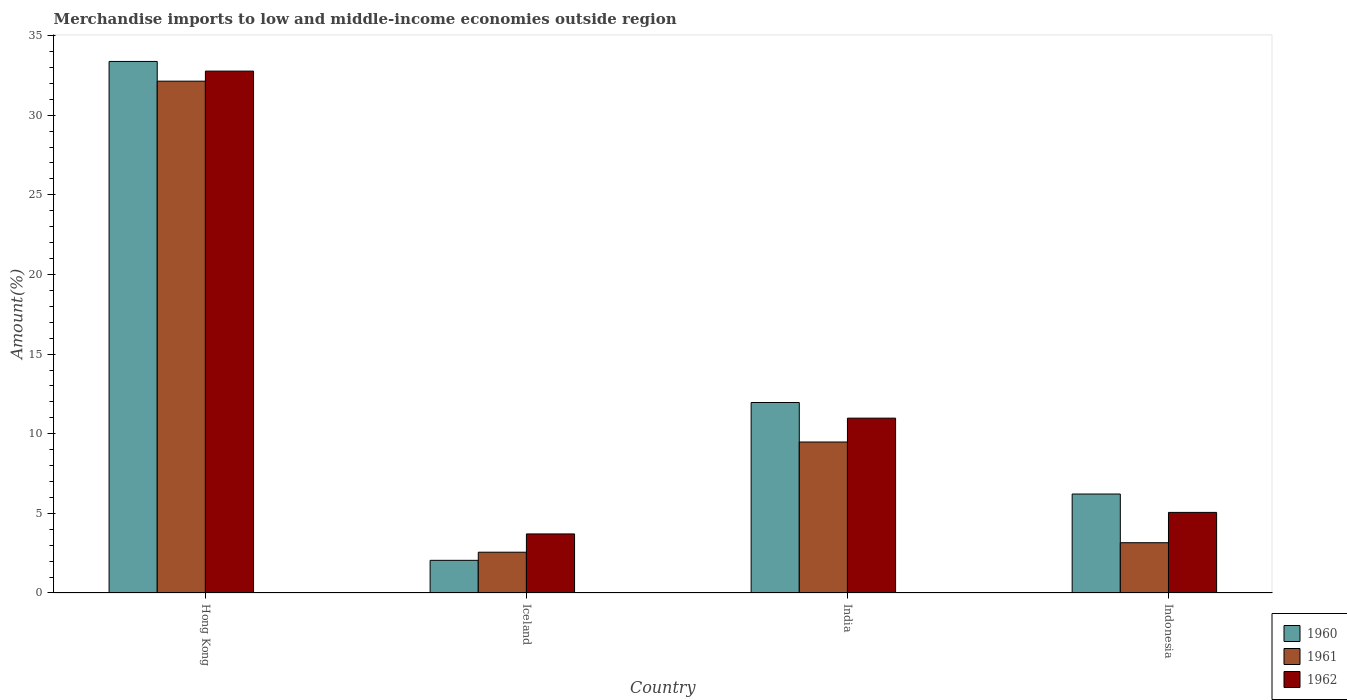How many bars are there on the 2nd tick from the left?
Give a very brief answer. 3. How many bars are there on the 3rd tick from the right?
Make the answer very short. 3. What is the label of the 4th group of bars from the left?
Your answer should be very brief. Indonesia. In how many cases, is the number of bars for a given country not equal to the number of legend labels?
Your answer should be compact. 0. What is the percentage of amount earned from merchandise imports in 1962 in Indonesia?
Offer a terse response. 5.06. Across all countries, what is the maximum percentage of amount earned from merchandise imports in 1961?
Offer a very short reply. 32.13. Across all countries, what is the minimum percentage of amount earned from merchandise imports in 1960?
Provide a short and direct response. 2.05. In which country was the percentage of amount earned from merchandise imports in 1962 maximum?
Make the answer very short. Hong Kong. What is the total percentage of amount earned from merchandise imports in 1960 in the graph?
Provide a short and direct response. 53.59. What is the difference between the percentage of amount earned from merchandise imports in 1962 in India and that in Indonesia?
Offer a very short reply. 5.92. What is the difference between the percentage of amount earned from merchandise imports in 1960 in India and the percentage of amount earned from merchandise imports in 1962 in Hong Kong?
Keep it short and to the point. -20.81. What is the average percentage of amount earned from merchandise imports in 1961 per country?
Your answer should be compact. 11.83. What is the difference between the percentage of amount earned from merchandise imports of/in 1961 and percentage of amount earned from merchandise imports of/in 1962 in Iceland?
Your answer should be very brief. -1.15. In how many countries, is the percentage of amount earned from merchandise imports in 1961 greater than 15 %?
Keep it short and to the point. 1. What is the ratio of the percentage of amount earned from merchandise imports in 1962 in Iceland to that in India?
Keep it short and to the point. 0.34. What is the difference between the highest and the second highest percentage of amount earned from merchandise imports in 1961?
Provide a succinct answer. 22.66. What is the difference between the highest and the lowest percentage of amount earned from merchandise imports in 1962?
Provide a succinct answer. 29.06. In how many countries, is the percentage of amount earned from merchandise imports in 1961 greater than the average percentage of amount earned from merchandise imports in 1961 taken over all countries?
Keep it short and to the point. 1. What does the 2nd bar from the left in India represents?
Your response must be concise. 1961. What does the 1st bar from the right in Iceland represents?
Your answer should be very brief. 1962. Is it the case that in every country, the sum of the percentage of amount earned from merchandise imports in 1961 and percentage of amount earned from merchandise imports in 1962 is greater than the percentage of amount earned from merchandise imports in 1960?
Give a very brief answer. Yes. How many bars are there?
Your answer should be very brief. 12. How many countries are there in the graph?
Make the answer very short. 4. Are the values on the major ticks of Y-axis written in scientific E-notation?
Provide a short and direct response. No. How are the legend labels stacked?
Provide a short and direct response. Vertical. What is the title of the graph?
Your answer should be very brief. Merchandise imports to low and middle-income economies outside region. Does "1981" appear as one of the legend labels in the graph?
Ensure brevity in your answer.  No. What is the label or title of the X-axis?
Provide a succinct answer. Country. What is the label or title of the Y-axis?
Your response must be concise. Amount(%). What is the Amount(%) in 1960 in Hong Kong?
Make the answer very short. 33.37. What is the Amount(%) of 1961 in Hong Kong?
Your response must be concise. 32.13. What is the Amount(%) in 1962 in Hong Kong?
Your answer should be very brief. 32.77. What is the Amount(%) of 1960 in Iceland?
Offer a terse response. 2.05. What is the Amount(%) in 1961 in Iceland?
Your answer should be very brief. 2.56. What is the Amount(%) in 1962 in Iceland?
Your answer should be compact. 3.71. What is the Amount(%) in 1960 in India?
Your answer should be very brief. 11.96. What is the Amount(%) of 1961 in India?
Ensure brevity in your answer.  9.48. What is the Amount(%) of 1962 in India?
Your answer should be compact. 10.98. What is the Amount(%) of 1960 in Indonesia?
Provide a short and direct response. 6.21. What is the Amount(%) in 1961 in Indonesia?
Your answer should be compact. 3.16. What is the Amount(%) in 1962 in Indonesia?
Make the answer very short. 5.06. Across all countries, what is the maximum Amount(%) of 1960?
Keep it short and to the point. 33.37. Across all countries, what is the maximum Amount(%) of 1961?
Provide a succinct answer. 32.13. Across all countries, what is the maximum Amount(%) in 1962?
Keep it short and to the point. 32.77. Across all countries, what is the minimum Amount(%) of 1960?
Ensure brevity in your answer.  2.05. Across all countries, what is the minimum Amount(%) of 1961?
Offer a very short reply. 2.56. Across all countries, what is the minimum Amount(%) in 1962?
Your answer should be compact. 3.71. What is the total Amount(%) of 1960 in the graph?
Make the answer very short. 53.59. What is the total Amount(%) of 1961 in the graph?
Your response must be concise. 47.33. What is the total Amount(%) of 1962 in the graph?
Offer a terse response. 52.51. What is the difference between the Amount(%) of 1960 in Hong Kong and that in Iceland?
Your answer should be very brief. 31.32. What is the difference between the Amount(%) in 1961 in Hong Kong and that in Iceland?
Provide a succinct answer. 29.57. What is the difference between the Amount(%) in 1962 in Hong Kong and that in Iceland?
Keep it short and to the point. 29.06. What is the difference between the Amount(%) in 1960 in Hong Kong and that in India?
Make the answer very short. 21.41. What is the difference between the Amount(%) in 1961 in Hong Kong and that in India?
Provide a short and direct response. 22.66. What is the difference between the Amount(%) of 1962 in Hong Kong and that in India?
Offer a very short reply. 21.79. What is the difference between the Amount(%) of 1960 in Hong Kong and that in Indonesia?
Keep it short and to the point. 27.16. What is the difference between the Amount(%) in 1961 in Hong Kong and that in Indonesia?
Give a very brief answer. 28.98. What is the difference between the Amount(%) of 1962 in Hong Kong and that in Indonesia?
Provide a short and direct response. 27.71. What is the difference between the Amount(%) in 1960 in Iceland and that in India?
Provide a short and direct response. -9.91. What is the difference between the Amount(%) in 1961 in Iceland and that in India?
Offer a terse response. -6.92. What is the difference between the Amount(%) of 1962 in Iceland and that in India?
Provide a succinct answer. -7.27. What is the difference between the Amount(%) of 1960 in Iceland and that in Indonesia?
Your answer should be very brief. -4.16. What is the difference between the Amount(%) in 1961 in Iceland and that in Indonesia?
Ensure brevity in your answer.  -0.6. What is the difference between the Amount(%) in 1962 in Iceland and that in Indonesia?
Provide a succinct answer. -1.35. What is the difference between the Amount(%) of 1960 in India and that in Indonesia?
Your response must be concise. 5.75. What is the difference between the Amount(%) in 1961 in India and that in Indonesia?
Offer a very short reply. 6.32. What is the difference between the Amount(%) in 1962 in India and that in Indonesia?
Provide a succinct answer. 5.92. What is the difference between the Amount(%) in 1960 in Hong Kong and the Amount(%) in 1961 in Iceland?
Your response must be concise. 30.81. What is the difference between the Amount(%) of 1960 in Hong Kong and the Amount(%) of 1962 in Iceland?
Your answer should be compact. 29.66. What is the difference between the Amount(%) of 1961 in Hong Kong and the Amount(%) of 1962 in Iceland?
Provide a short and direct response. 28.43. What is the difference between the Amount(%) in 1960 in Hong Kong and the Amount(%) in 1961 in India?
Offer a very short reply. 23.89. What is the difference between the Amount(%) of 1960 in Hong Kong and the Amount(%) of 1962 in India?
Keep it short and to the point. 22.39. What is the difference between the Amount(%) of 1961 in Hong Kong and the Amount(%) of 1962 in India?
Your answer should be very brief. 21.16. What is the difference between the Amount(%) in 1960 in Hong Kong and the Amount(%) in 1961 in Indonesia?
Ensure brevity in your answer.  30.22. What is the difference between the Amount(%) in 1960 in Hong Kong and the Amount(%) in 1962 in Indonesia?
Make the answer very short. 28.31. What is the difference between the Amount(%) of 1961 in Hong Kong and the Amount(%) of 1962 in Indonesia?
Your answer should be very brief. 27.07. What is the difference between the Amount(%) of 1960 in Iceland and the Amount(%) of 1961 in India?
Ensure brevity in your answer.  -7.43. What is the difference between the Amount(%) in 1960 in Iceland and the Amount(%) in 1962 in India?
Make the answer very short. -8.93. What is the difference between the Amount(%) in 1961 in Iceland and the Amount(%) in 1962 in India?
Make the answer very short. -8.42. What is the difference between the Amount(%) in 1960 in Iceland and the Amount(%) in 1961 in Indonesia?
Your answer should be very brief. -1.11. What is the difference between the Amount(%) of 1960 in Iceland and the Amount(%) of 1962 in Indonesia?
Your answer should be very brief. -3.01. What is the difference between the Amount(%) of 1961 in Iceland and the Amount(%) of 1962 in Indonesia?
Your answer should be compact. -2.5. What is the difference between the Amount(%) in 1960 in India and the Amount(%) in 1961 in Indonesia?
Keep it short and to the point. 8.8. What is the difference between the Amount(%) of 1960 in India and the Amount(%) of 1962 in Indonesia?
Give a very brief answer. 6.9. What is the difference between the Amount(%) in 1961 in India and the Amount(%) in 1962 in Indonesia?
Keep it short and to the point. 4.42. What is the average Amount(%) in 1960 per country?
Ensure brevity in your answer.  13.4. What is the average Amount(%) in 1961 per country?
Give a very brief answer. 11.83. What is the average Amount(%) of 1962 per country?
Your response must be concise. 13.13. What is the difference between the Amount(%) of 1960 and Amount(%) of 1961 in Hong Kong?
Provide a succinct answer. 1.24. What is the difference between the Amount(%) in 1960 and Amount(%) in 1962 in Hong Kong?
Offer a terse response. 0.61. What is the difference between the Amount(%) of 1961 and Amount(%) of 1962 in Hong Kong?
Give a very brief answer. -0.63. What is the difference between the Amount(%) in 1960 and Amount(%) in 1961 in Iceland?
Offer a terse response. -0.51. What is the difference between the Amount(%) of 1960 and Amount(%) of 1962 in Iceland?
Your response must be concise. -1.66. What is the difference between the Amount(%) of 1961 and Amount(%) of 1962 in Iceland?
Your answer should be very brief. -1.15. What is the difference between the Amount(%) in 1960 and Amount(%) in 1961 in India?
Offer a terse response. 2.48. What is the difference between the Amount(%) of 1960 and Amount(%) of 1962 in India?
Make the answer very short. 0.98. What is the difference between the Amount(%) in 1961 and Amount(%) in 1962 in India?
Keep it short and to the point. -1.5. What is the difference between the Amount(%) of 1960 and Amount(%) of 1961 in Indonesia?
Provide a short and direct response. 3.06. What is the difference between the Amount(%) of 1960 and Amount(%) of 1962 in Indonesia?
Offer a terse response. 1.15. What is the difference between the Amount(%) of 1961 and Amount(%) of 1962 in Indonesia?
Your answer should be compact. -1.9. What is the ratio of the Amount(%) of 1960 in Hong Kong to that in Iceland?
Keep it short and to the point. 16.28. What is the ratio of the Amount(%) in 1961 in Hong Kong to that in Iceland?
Your answer should be compact. 12.55. What is the ratio of the Amount(%) in 1962 in Hong Kong to that in Iceland?
Provide a succinct answer. 8.84. What is the ratio of the Amount(%) of 1960 in Hong Kong to that in India?
Your response must be concise. 2.79. What is the ratio of the Amount(%) in 1961 in Hong Kong to that in India?
Your response must be concise. 3.39. What is the ratio of the Amount(%) of 1962 in Hong Kong to that in India?
Offer a very short reply. 2.98. What is the ratio of the Amount(%) of 1960 in Hong Kong to that in Indonesia?
Ensure brevity in your answer.  5.37. What is the ratio of the Amount(%) of 1961 in Hong Kong to that in Indonesia?
Your answer should be compact. 10.18. What is the ratio of the Amount(%) of 1962 in Hong Kong to that in Indonesia?
Ensure brevity in your answer.  6.48. What is the ratio of the Amount(%) of 1960 in Iceland to that in India?
Provide a short and direct response. 0.17. What is the ratio of the Amount(%) of 1961 in Iceland to that in India?
Ensure brevity in your answer.  0.27. What is the ratio of the Amount(%) of 1962 in Iceland to that in India?
Your response must be concise. 0.34. What is the ratio of the Amount(%) in 1960 in Iceland to that in Indonesia?
Your response must be concise. 0.33. What is the ratio of the Amount(%) in 1961 in Iceland to that in Indonesia?
Your answer should be compact. 0.81. What is the ratio of the Amount(%) in 1962 in Iceland to that in Indonesia?
Give a very brief answer. 0.73. What is the ratio of the Amount(%) of 1960 in India to that in Indonesia?
Offer a terse response. 1.92. What is the ratio of the Amount(%) of 1961 in India to that in Indonesia?
Provide a succinct answer. 3. What is the ratio of the Amount(%) of 1962 in India to that in Indonesia?
Ensure brevity in your answer.  2.17. What is the difference between the highest and the second highest Amount(%) of 1960?
Offer a terse response. 21.41. What is the difference between the highest and the second highest Amount(%) in 1961?
Make the answer very short. 22.66. What is the difference between the highest and the second highest Amount(%) in 1962?
Your response must be concise. 21.79. What is the difference between the highest and the lowest Amount(%) of 1960?
Give a very brief answer. 31.32. What is the difference between the highest and the lowest Amount(%) of 1961?
Give a very brief answer. 29.57. What is the difference between the highest and the lowest Amount(%) of 1962?
Keep it short and to the point. 29.06. 